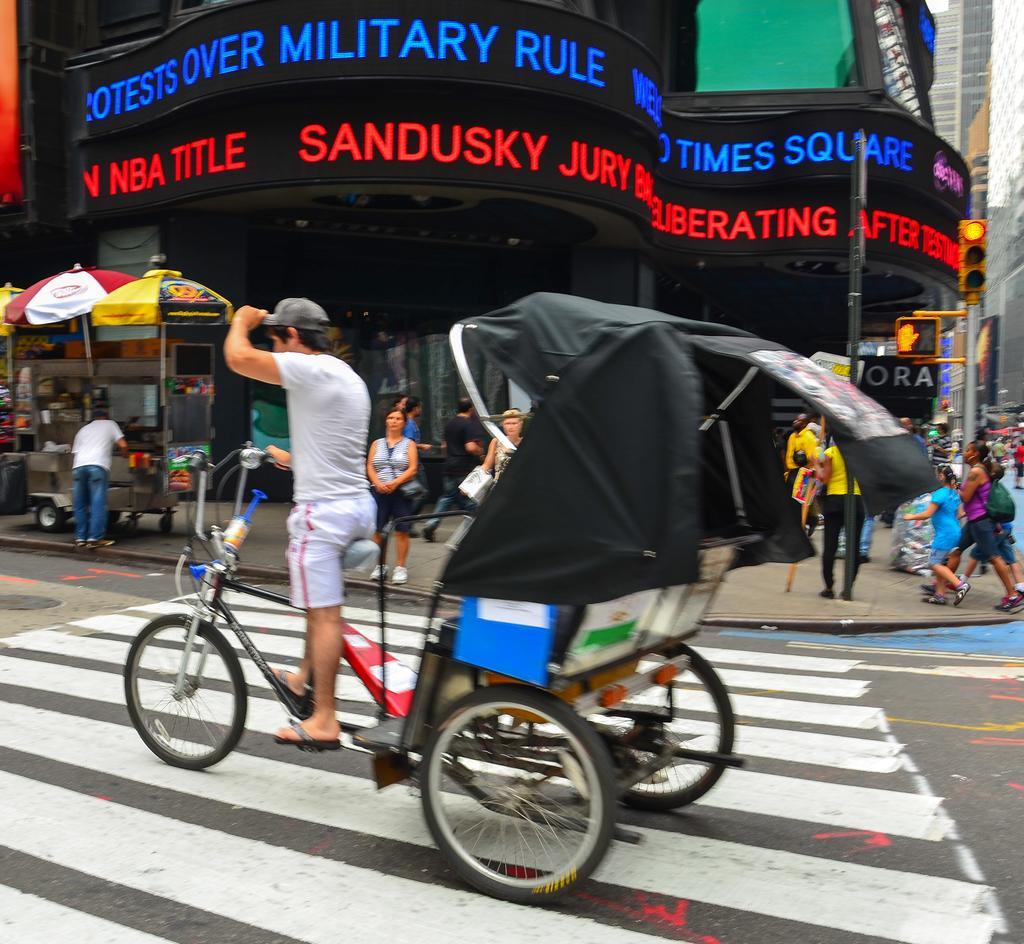Can you describe this image briefly? In the picture I can see buildings, people among them some are standing and some are walking on the ground. I can also see a person is sitting on a bicycle. In the background I can see traffic lights, poles, umbrellas and some other objects. 